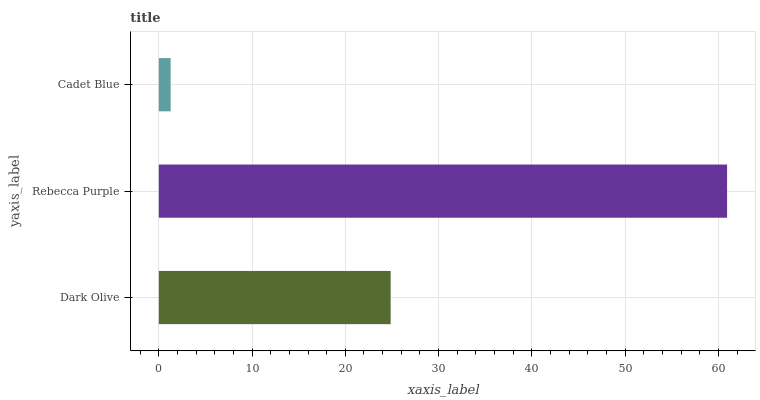Is Cadet Blue the minimum?
Answer yes or no. Yes. Is Rebecca Purple the maximum?
Answer yes or no. Yes. Is Rebecca Purple the minimum?
Answer yes or no. No. Is Cadet Blue the maximum?
Answer yes or no. No. Is Rebecca Purple greater than Cadet Blue?
Answer yes or no. Yes. Is Cadet Blue less than Rebecca Purple?
Answer yes or no. Yes. Is Cadet Blue greater than Rebecca Purple?
Answer yes or no. No. Is Rebecca Purple less than Cadet Blue?
Answer yes or no. No. Is Dark Olive the high median?
Answer yes or no. Yes. Is Dark Olive the low median?
Answer yes or no. Yes. Is Rebecca Purple the high median?
Answer yes or no. No. Is Rebecca Purple the low median?
Answer yes or no. No. 